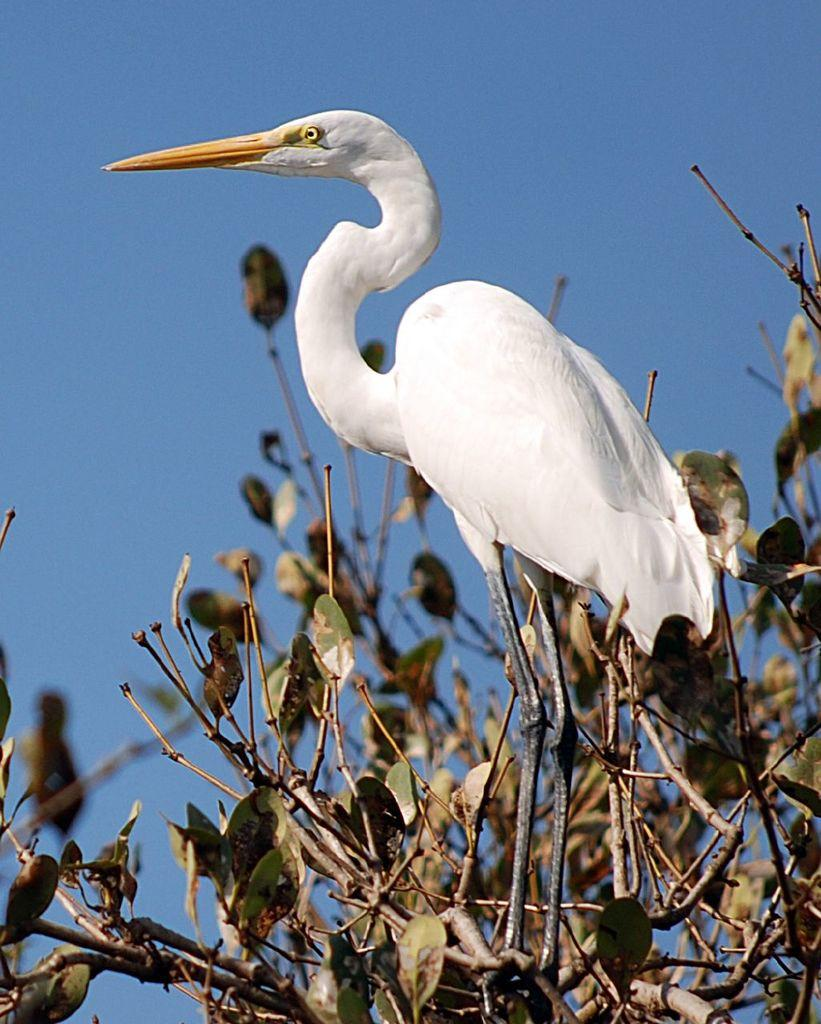What is located in the foreground of the image? There is a crane and a tree in the foreground of the image. Can you describe the crane in the image? The crane is a large machine used for lifting and moving heavy objects. What can be seen in the background of the image? The sky is visible in the background of the image. How many ants can be seen crawling on the tree in the image? There are no ants visible on the tree in the image. What type of store is located near the crane in the image? There is no store present in the image; it features a crane and a tree in the foreground and the sky in the background. 